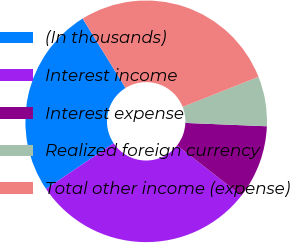Convert chart to OTSL. <chart><loc_0><loc_0><loc_500><loc_500><pie_chart><fcel>(In thousands)<fcel>Interest income<fcel>Interest expense<fcel>Realized foreign currency<fcel>Total other income (expense)<nl><fcel>25.63%<fcel>30.01%<fcel>9.89%<fcel>6.65%<fcel>27.82%<nl></chart> 